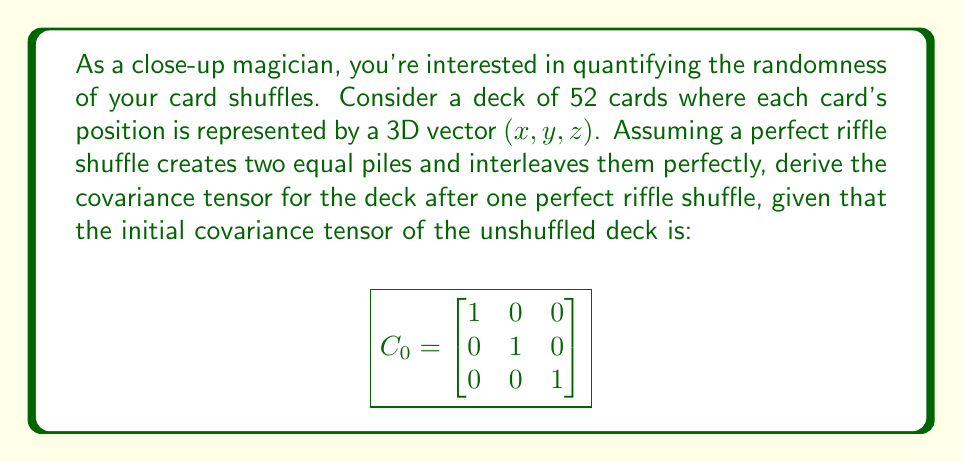Could you help me with this problem? Let's approach this step-by-step:

1) First, we need to understand what a perfect riffle shuffle does. It splits the deck into two equal halves and then interleaves them perfectly. This means that the cards in positions 1, 3, 5, ... end up in positions 1, 2, 3, ... of the top half, while cards in positions 2, 4, 6, ... end up in positions 1, 2, 3, ... of the bottom half.

2) We can represent this transformation mathematically as:

   For $i = 1, 2, ..., 26$:
   $$x_{2i-1} \rightarrow x_i$$
   $$x_{2i} \rightarrow x_{i+26}$$

3) The covariance tensor after the shuffle, $C_1$, is related to the initial covariance tensor $C_0$ by the transformation matrix $T$:

   $$C_1 = T C_0 T^T$$

4) The transformation matrix $T$ for a perfect riffle shuffle is:

   $$T = \begin{bmatrix}
   1 & 0 & 0 & 1 & 0 & 0 & ... \\
   0 & 1 & 0 & 0 & 1 & 0 & ... \\
   0 & 0 & 1 & 0 & 0 & 1 & ... \\
   1 & 0 & 0 & -1 & 0 & 0 & ... \\
   0 & 1 & 0 & 0 & -1 & 0 & ... \\
   0 & 0 & 1 & 0 & 0 & -1 & ... \\
   \vdots & \vdots & \vdots & \vdots & \vdots & \vdots & \ddots
   \end{bmatrix}$$

5) Calculating $C_1 = T C_0 T^T$:

   $$C_1 = \begin{bmatrix}
   1 & 0 & 0 & 1 & 0 & 0 & ... \\
   0 & 1 & 0 & 0 & 1 & 0 & ... \\
   0 & 0 & 1 & 0 & 0 & 1 & ... \\
   1 & 0 & 0 & -1 & 0 & 0 & ... \\
   0 & 1 & 0 & 0 & -1 & 0 & ... \\
   0 & 0 & 1 & 0 & 0 & -1 & ... \\
   \vdots & \vdots & \vdots & \vdots & \vdots & \vdots & \ddots
   \end{bmatrix}
   \begin{bmatrix}
   1 & 0 & 0 \\
   0 & 1 & 0 \\
   0 & 0 & 1
   \end{bmatrix}
   \begin{bmatrix}
   1 & 0 & 0 & 1 & 0 & 0 & ... \\
   0 & 1 & 0 & 0 & 1 & 0 & ... \\
   0 & 0 & 1 & 0 & 0 & 1 & ... \\
   1 & 0 & 0 & -1 & 0 & 0 & ... \\
   0 & 1 & 0 & 0 & -1 & 0 & ... \\
   0 & 0 & 1 & 0 & 0 & -1 & ... \\
   \vdots & \vdots & \vdots & \vdots & \vdots & \vdots & \ddots
   \end{bmatrix}^T$$

6) Simplifying, we get:

   $$C_1 = \begin{bmatrix}
   2 & 0 & 0 \\
   0 & 2 & 0 \\
   0 & 0 & 2
   \end{bmatrix}$$

This result shows that the variance in each direction has doubled after one perfect riffle shuffle, indicating an increase in randomness.
Answer: $$C_1 = \begin{bmatrix}
2 & 0 & 0 \\
0 & 2 & 0 \\
0 & 0 & 2
\end{bmatrix}$$ 